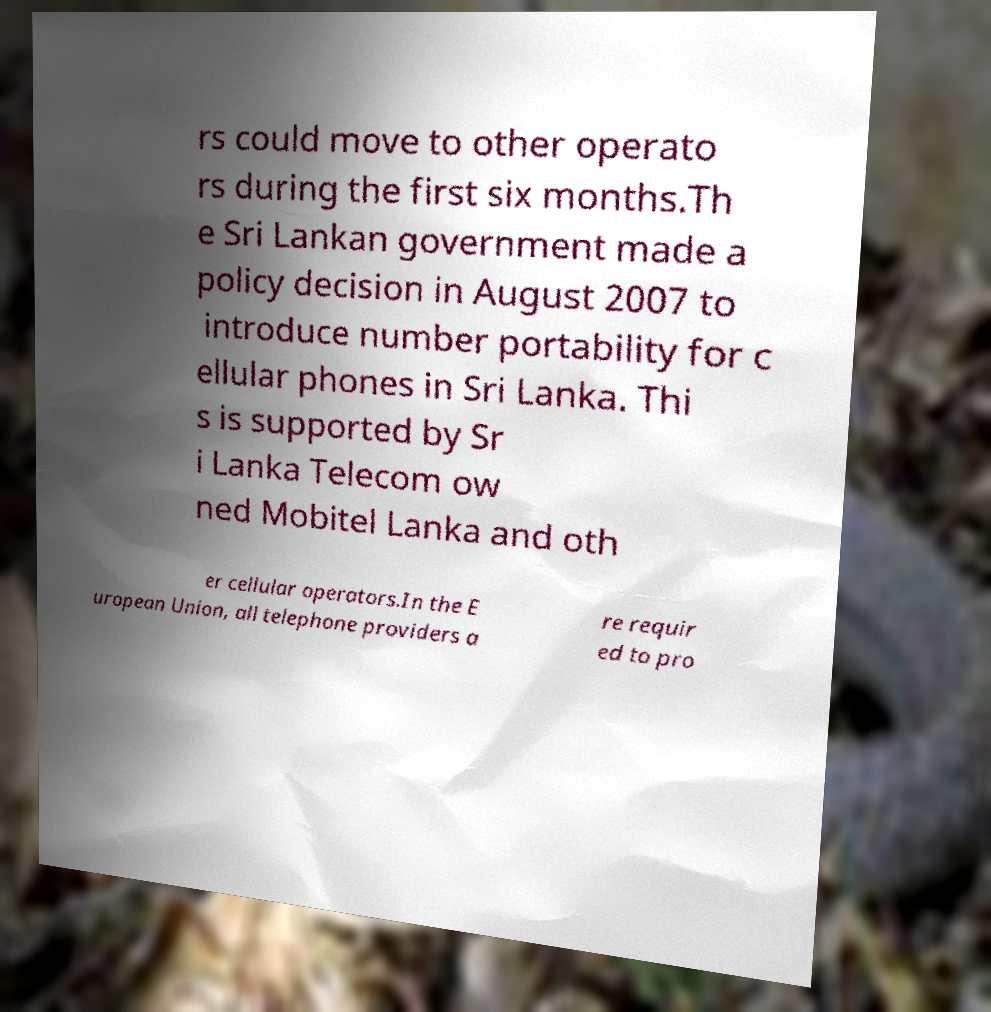For documentation purposes, I need the text within this image transcribed. Could you provide that? rs could move to other operato rs during the first six months.Th e Sri Lankan government made a policy decision in August 2007 to introduce number portability for c ellular phones in Sri Lanka. Thi s is supported by Sr i Lanka Telecom ow ned Mobitel Lanka and oth er cellular operators.In the E uropean Union, all telephone providers a re requir ed to pro 